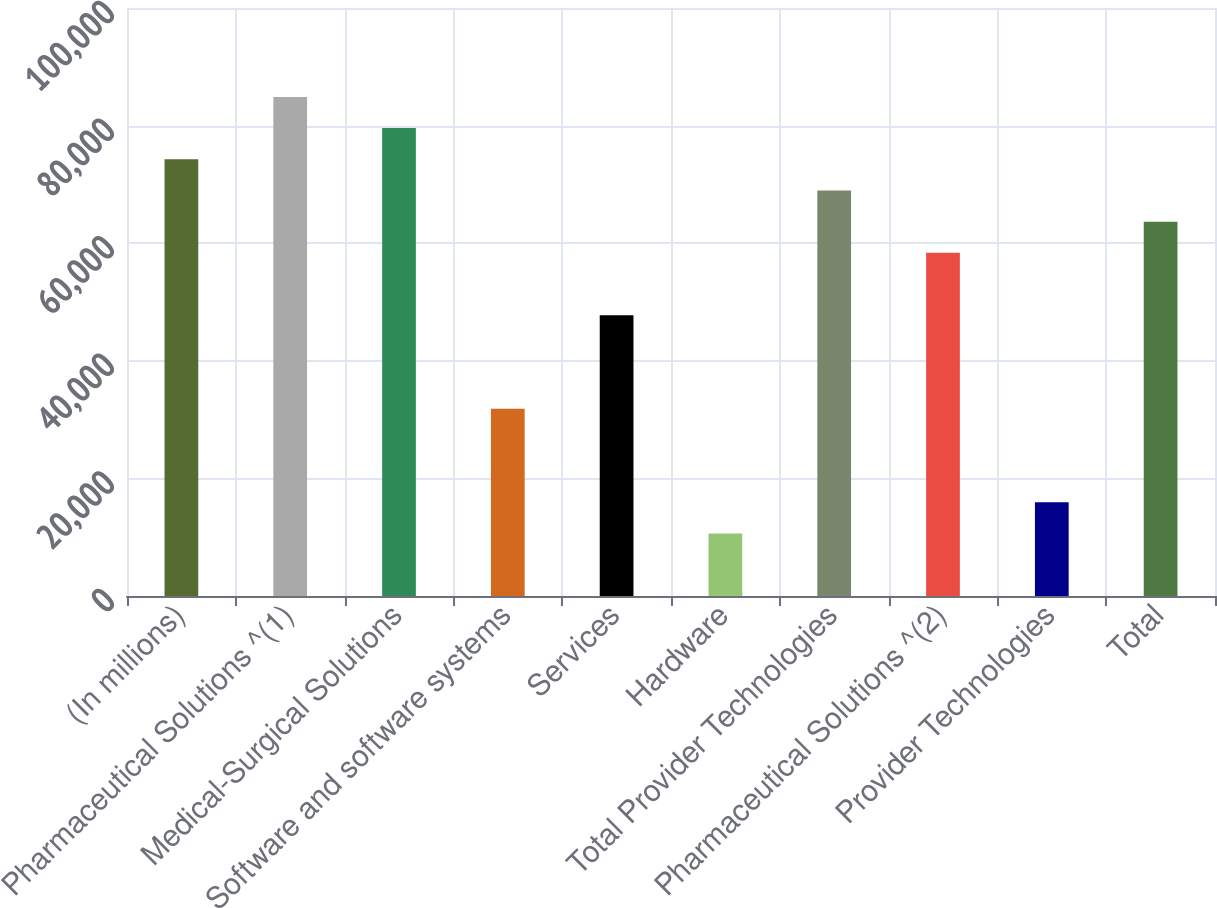<chart> <loc_0><loc_0><loc_500><loc_500><bar_chart><fcel>(In millions)<fcel>Pharmaceutical Solutions ^(1)<fcel>Medical-Surgical Solutions<fcel>Software and software systems<fcel>Services<fcel>Hardware<fcel>Total Provider Technologies<fcel>Pharmaceutical Solutions ^(2)<fcel>Provider Technologies<fcel>Total<nl><fcel>74273.3<fcel>84880.6<fcel>79576.9<fcel>31844.3<fcel>47755.2<fcel>10629.8<fcel>68969.7<fcel>58362.4<fcel>15933.4<fcel>63666.1<nl></chart> 